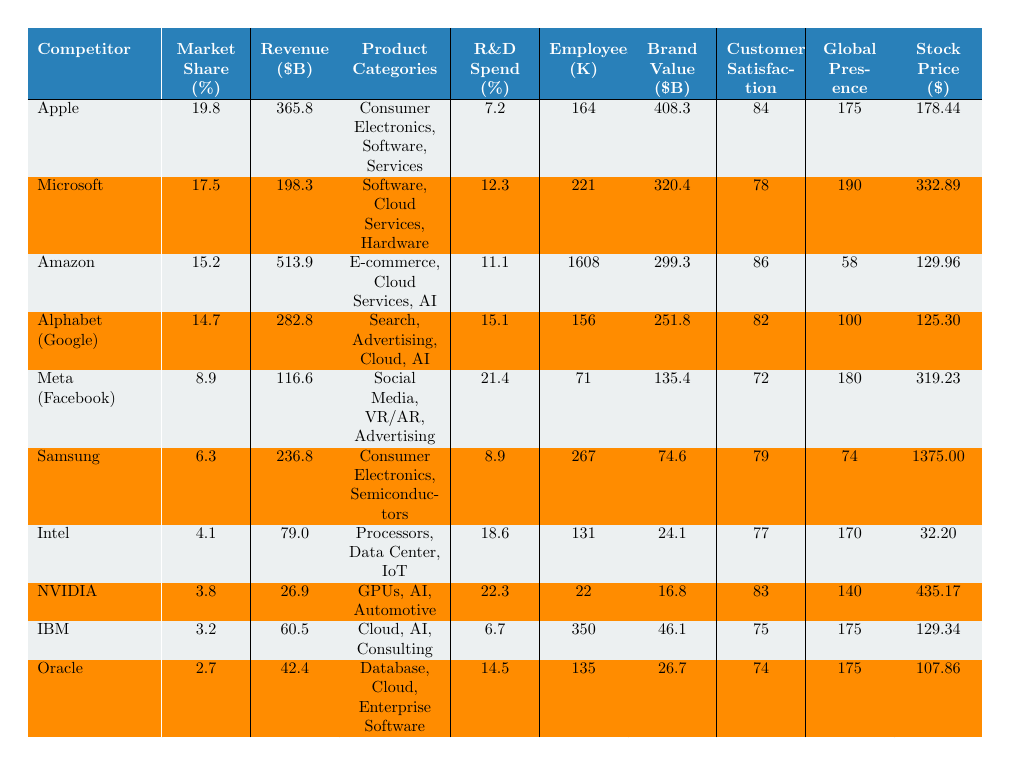What is the market share percentage of Apple? According to the table, Apple has a market share percentage of 19.8%.
Answer: 19.8% Which competitor has the highest revenue? The table indicates that Amazon has the highest revenue at 513.9 billion USD.
Answer: Amazon What is the product category for NVIDIA? The product categories listed for NVIDIA are GPUs, AI, and Automotive.
Answer: GPUs, AI, Automotive Calculate the average R&D spend percentage of the competitors. The R&D spend percentages are: 7.2, 12.3, 11.1, 15.1, 21.4, 8.9, 18.6, 22.3, 6.7, and 14.5. Their sum is  7.2 + 12.3 + 11.1 + 15.1 + 21.4 + 8.9 + 18.6 + 22.3 + 6.7 + 14.5 =  138.1. Dividing by 10 gives an average of 138.1 / 10 = 13.81.
Answer: 13.81 Does any competitor have a customer satisfaction score above 85? Yes, both Apple (84) and Amazon (86) have a customer satisfaction score above 85.
Answer: Yes Who has a greater employee count, Microsoft or IBM? Microsoft has an employee count of 221, while IBM has 350. Since 221 < 350, IBM has a greater employee count.
Answer: IBM What is the total market share percentage of the top three competitors? The top three competitors are Apple (19.8%), Microsoft (17.5%), and Amazon (15.2%). Adding these gives: 19.8 + 17.5 + 15.2 = 52.5%.
Answer: 52.5% Does Samsung have the highest brand value among competitors listed? No, Samsung’s brand value is 74.6 billion USD, which is lower than Apple (408.3 billion USD) and Microsoft (320.4 billion USD).
Answer: No Which competitor has the lowest stock price? The stock price listed for Intel is the lowest at 32.20 USD.
Answer: Intel What is the difference in market share between the top two competitors? The market share for Apple is 19.8%, and for Microsoft, it is 17.5%. The difference is 19.8 - 17.5 = 2.3%.
Answer: 2.3% 